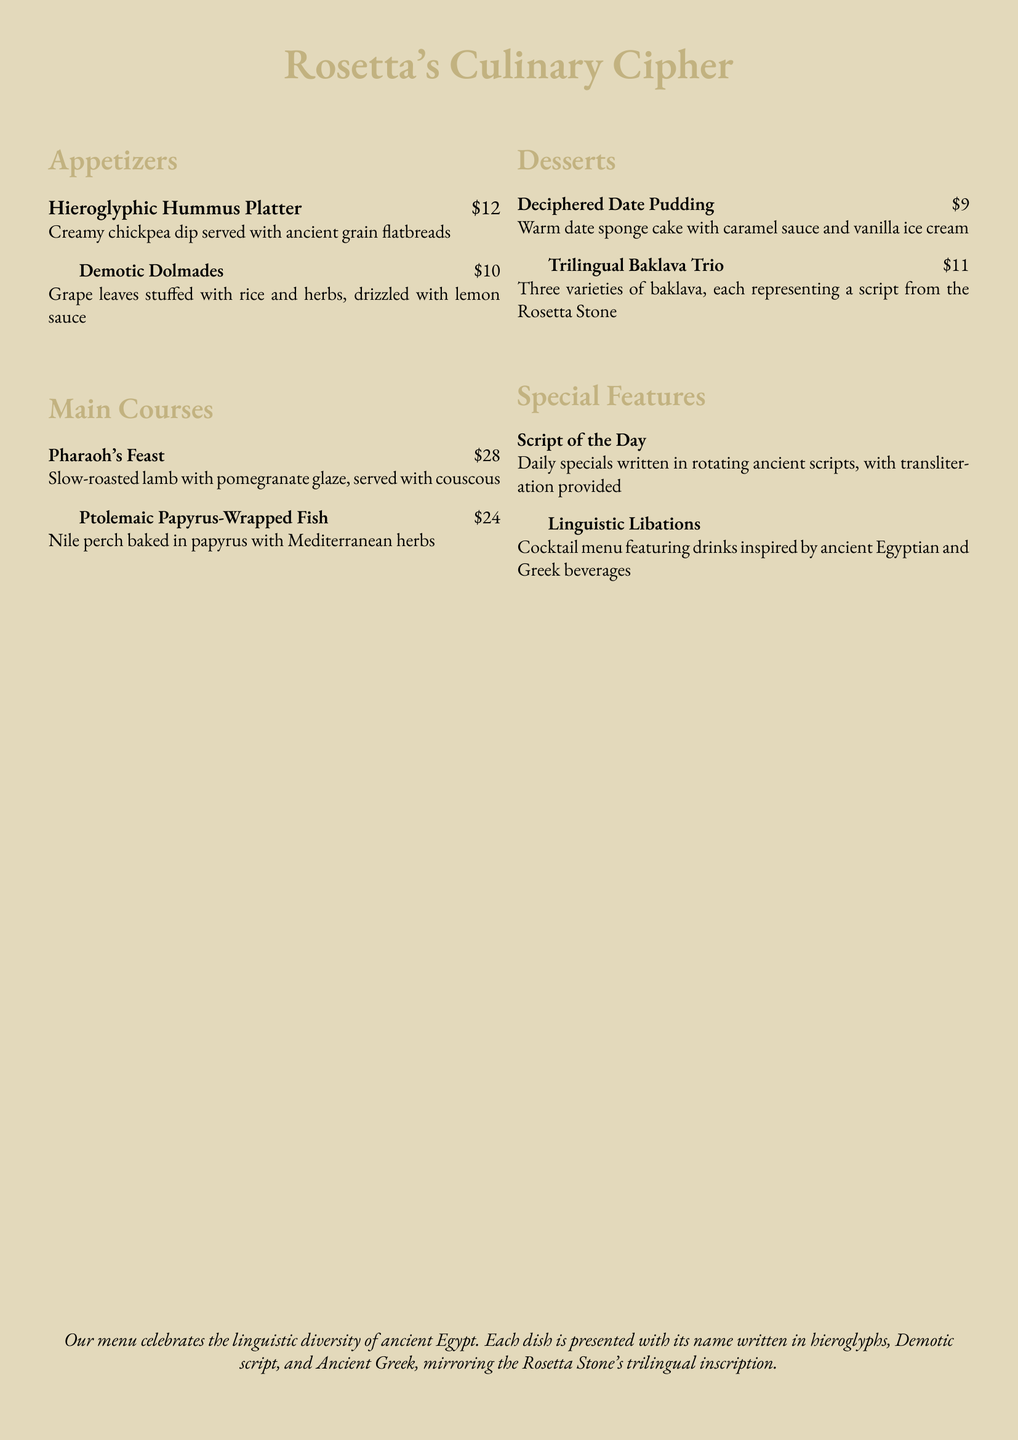What is the name of the appetizer that features chickpea dip? The name of the appetizer is listed under the Appetizers section, which is "Hieroglyphic Hummus Platter."
Answer: Hieroglyphic Hummus Platter How much does the Ptolemaic Papyrus-Wrapped Fish cost? The cost for the Ptolemaic Papyrus-Wrapped Fish is shown in the Main Courses section.
Answer: $24 What is the name of the dessert that has warm date sponge cake? The dessert is identified in the Desserts section as "Deciphered Date Pudding."
Answer: Deciphered Date Pudding What is featured in the 'Script of the Day'? 'Script of the Day' details daily specials that are represented in various ancient scripts.
Answer: Daily specials written in rotating ancient scripts Which dish includes pomegranate glaze? The dish with pomegranate glaze is found in the Main Courses section, specifically "Pharaoh's Feast."
Answer: Pharaoh's Feast How many varieties are there in the Trilingual Baklava Trio? The Trilingual Baklava Trio consists of three different types of baklava.
Answer: Three varieties 